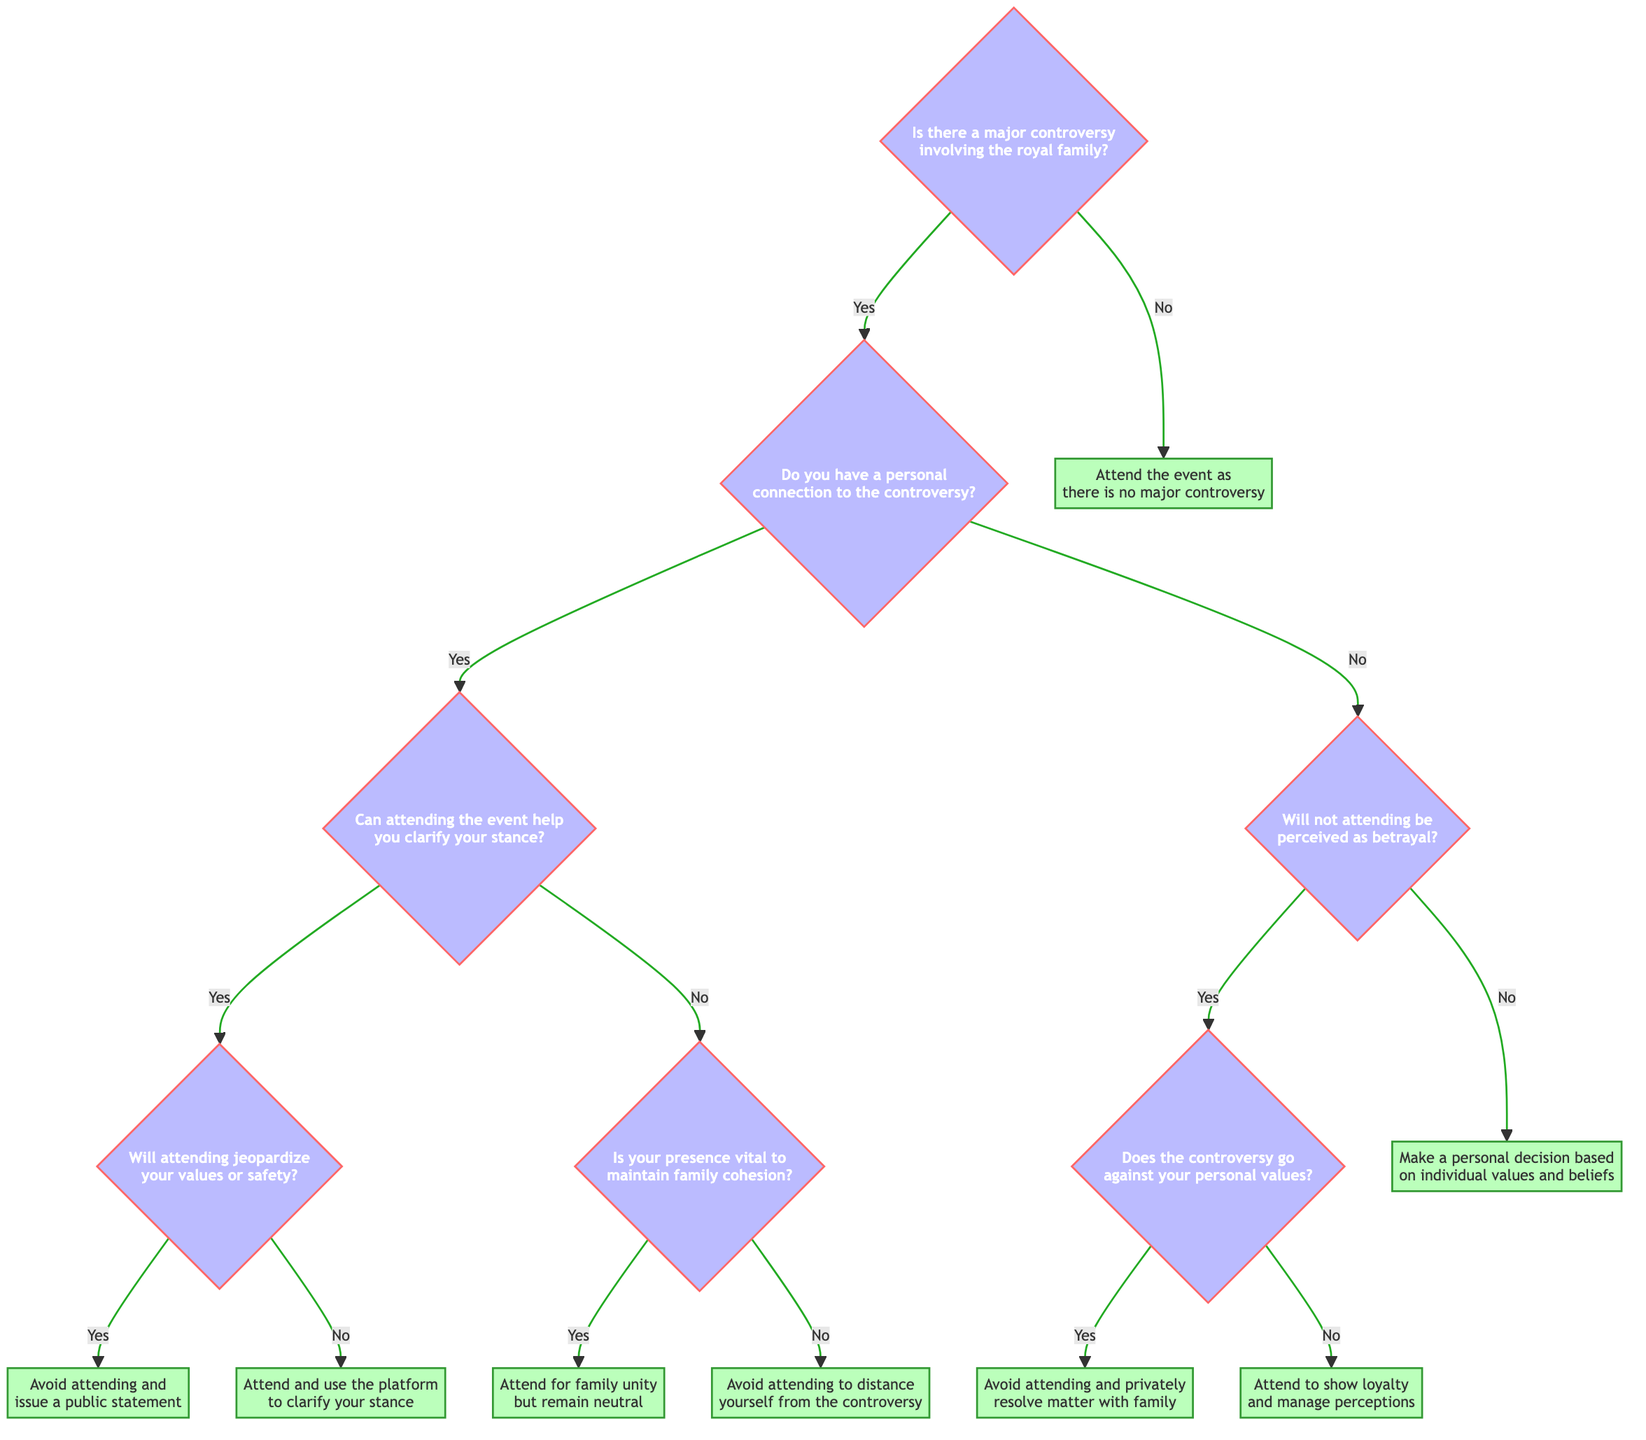What is the first question in the decision tree? The first question in the decision tree is located at the top node labeled "Is there a major controversy involving the royal family?" This is the starting point for determining the decision path.
Answer: Is there a major controversy involving the royal family? How many choices lead from the second question? The second question is "Do you have a personal connection to the controversy?" It leads to two choices: one for 'yes' and one for 'no', so there are two choices total.
Answer: Two choices What choice follows if the answer to "Can attending the event help you clarify your stance to the public?" is 'no'? If the answer to "Can attending the event help you clarify your stance to the public?" is 'no', the subsequent choice is "Avoid attending to distance yourself from the controversy."
Answer: Avoid attending to distance yourself from the controversy If the answer to "Will not attending be perceived as betrayal or disloyalty?" is 'yes' and the controversy goes against personal values, what should be the decision? If the answer to "Will not attending be perceived as betrayal or disloyalty?" is 'yes' and the controversy indeed goes against personal values, the decision is to "Avoid attending and privately resolve the matter with the family." This combines two conditions leading to a specific endpoint.
Answer: Avoid attending and privately resolve the matter with the family What is the final outcome if there is no major controversy? The final outcome when there is no major controversy is straightforward: the choice is to "Attend the event as there is no major controversy." This indicates that absence of controversy directly allows for attendance.
Answer: Attend the event as there is no major controversy What decision is made if attending could jeopardize personal values or safety? If attending the event is determined to jeopardize personal values or safety, the decision made is to "Avoid attending and issue a public statement." This reflects prioritizing personal integrity and safety over attendance.
Answer: Avoid attending and issue a public statement 